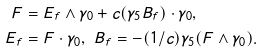Convert formula to latex. <formula><loc_0><loc_0><loc_500><loc_500>F & = E _ { f } \wedge \gamma _ { 0 } + c ( \gamma _ { 5 } B _ { f } ) \cdot \gamma _ { 0 } , \\ E _ { f } & = F \cdot \gamma _ { 0 } , \ B _ { f } = - ( 1 / c ) \gamma _ { 5 } ( F \wedge \gamma _ { 0 } ) .</formula> 